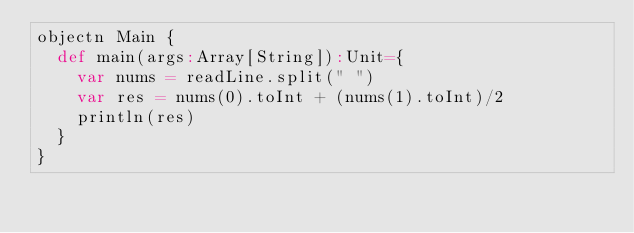Convert code to text. <code><loc_0><loc_0><loc_500><loc_500><_Scala_>objectn Main {
  def main(args:Array[String]):Unit={
    var nums = readLine.split(" ")
    var res = nums(0).toInt + (nums(1).toInt)/2
    println(res)
  }
}
</code> 